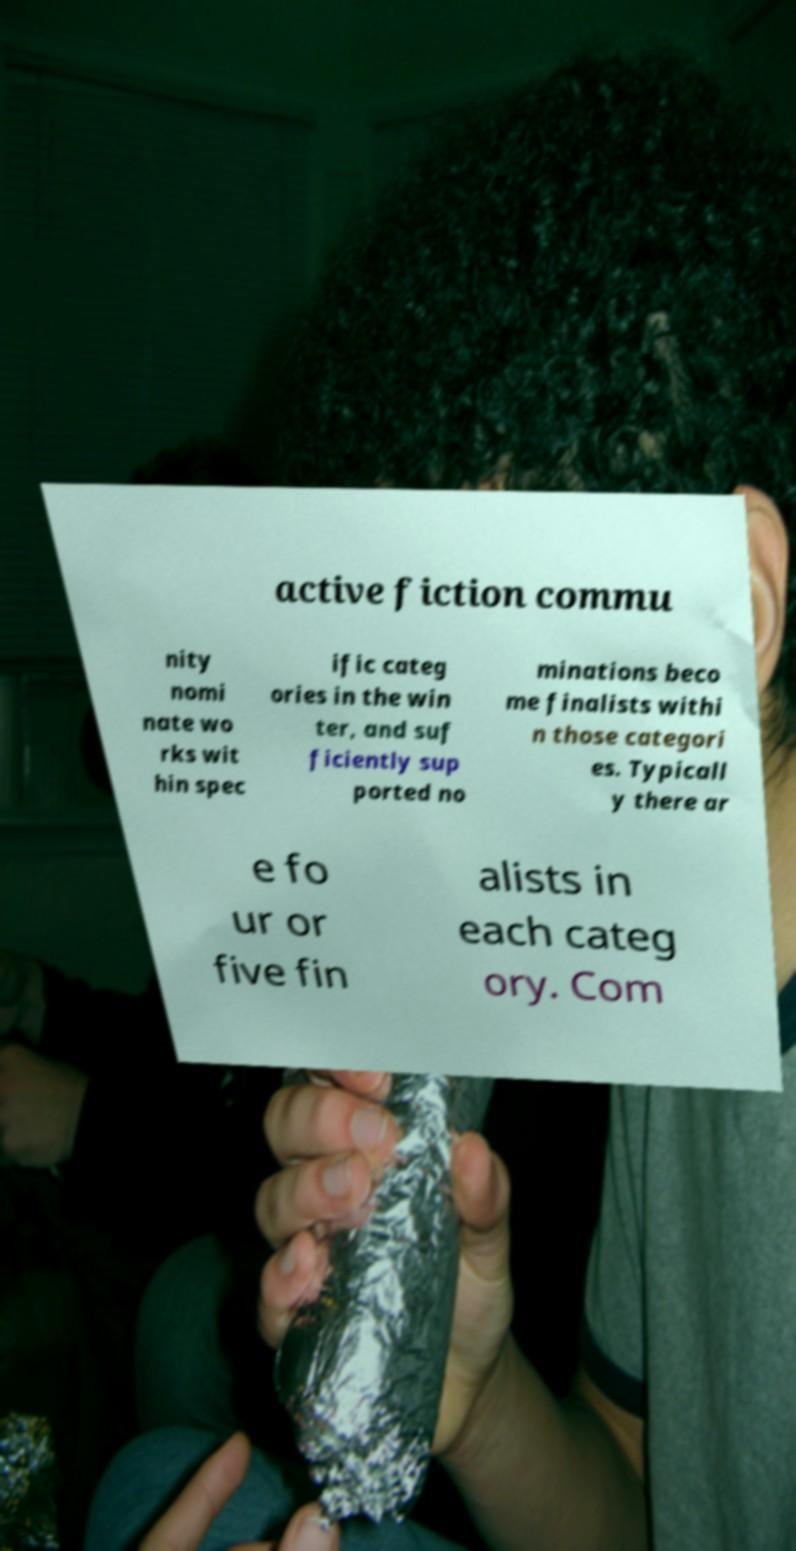Can you read and provide the text displayed in the image?This photo seems to have some interesting text. Can you extract and type it out for me? active fiction commu nity nomi nate wo rks wit hin spec ific categ ories in the win ter, and suf ficiently sup ported no minations beco me finalists withi n those categori es. Typicall y there ar e fo ur or five fin alists in each categ ory. Com 